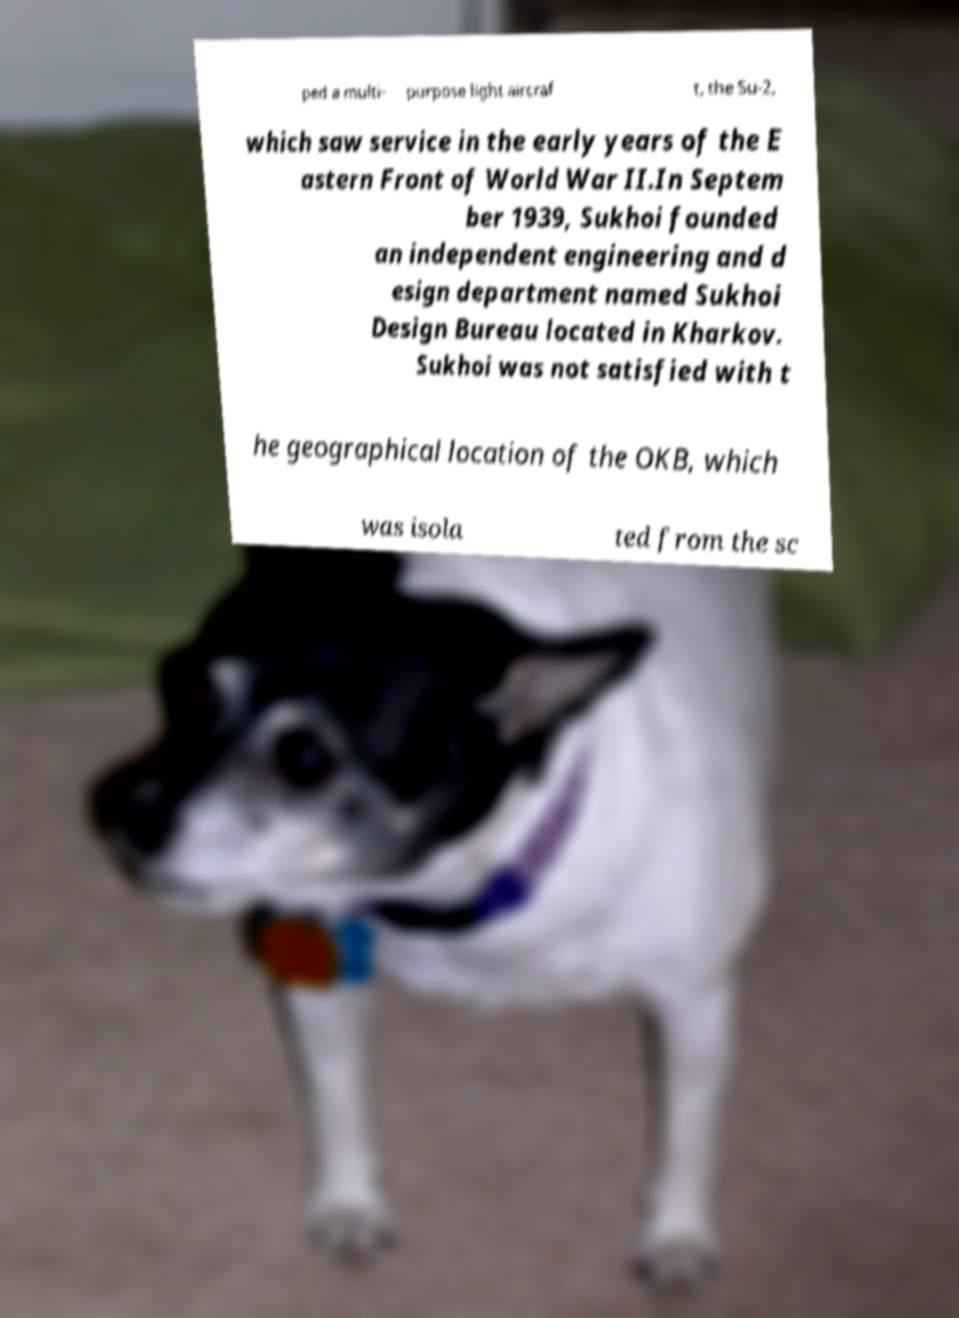Can you read and provide the text displayed in the image?This photo seems to have some interesting text. Can you extract and type it out for me? ped a multi- purpose light aircraf t, the Su-2, which saw service in the early years of the E astern Front of World War II.In Septem ber 1939, Sukhoi founded an independent engineering and d esign department named Sukhoi Design Bureau located in Kharkov. Sukhoi was not satisfied with t he geographical location of the OKB, which was isola ted from the sc 